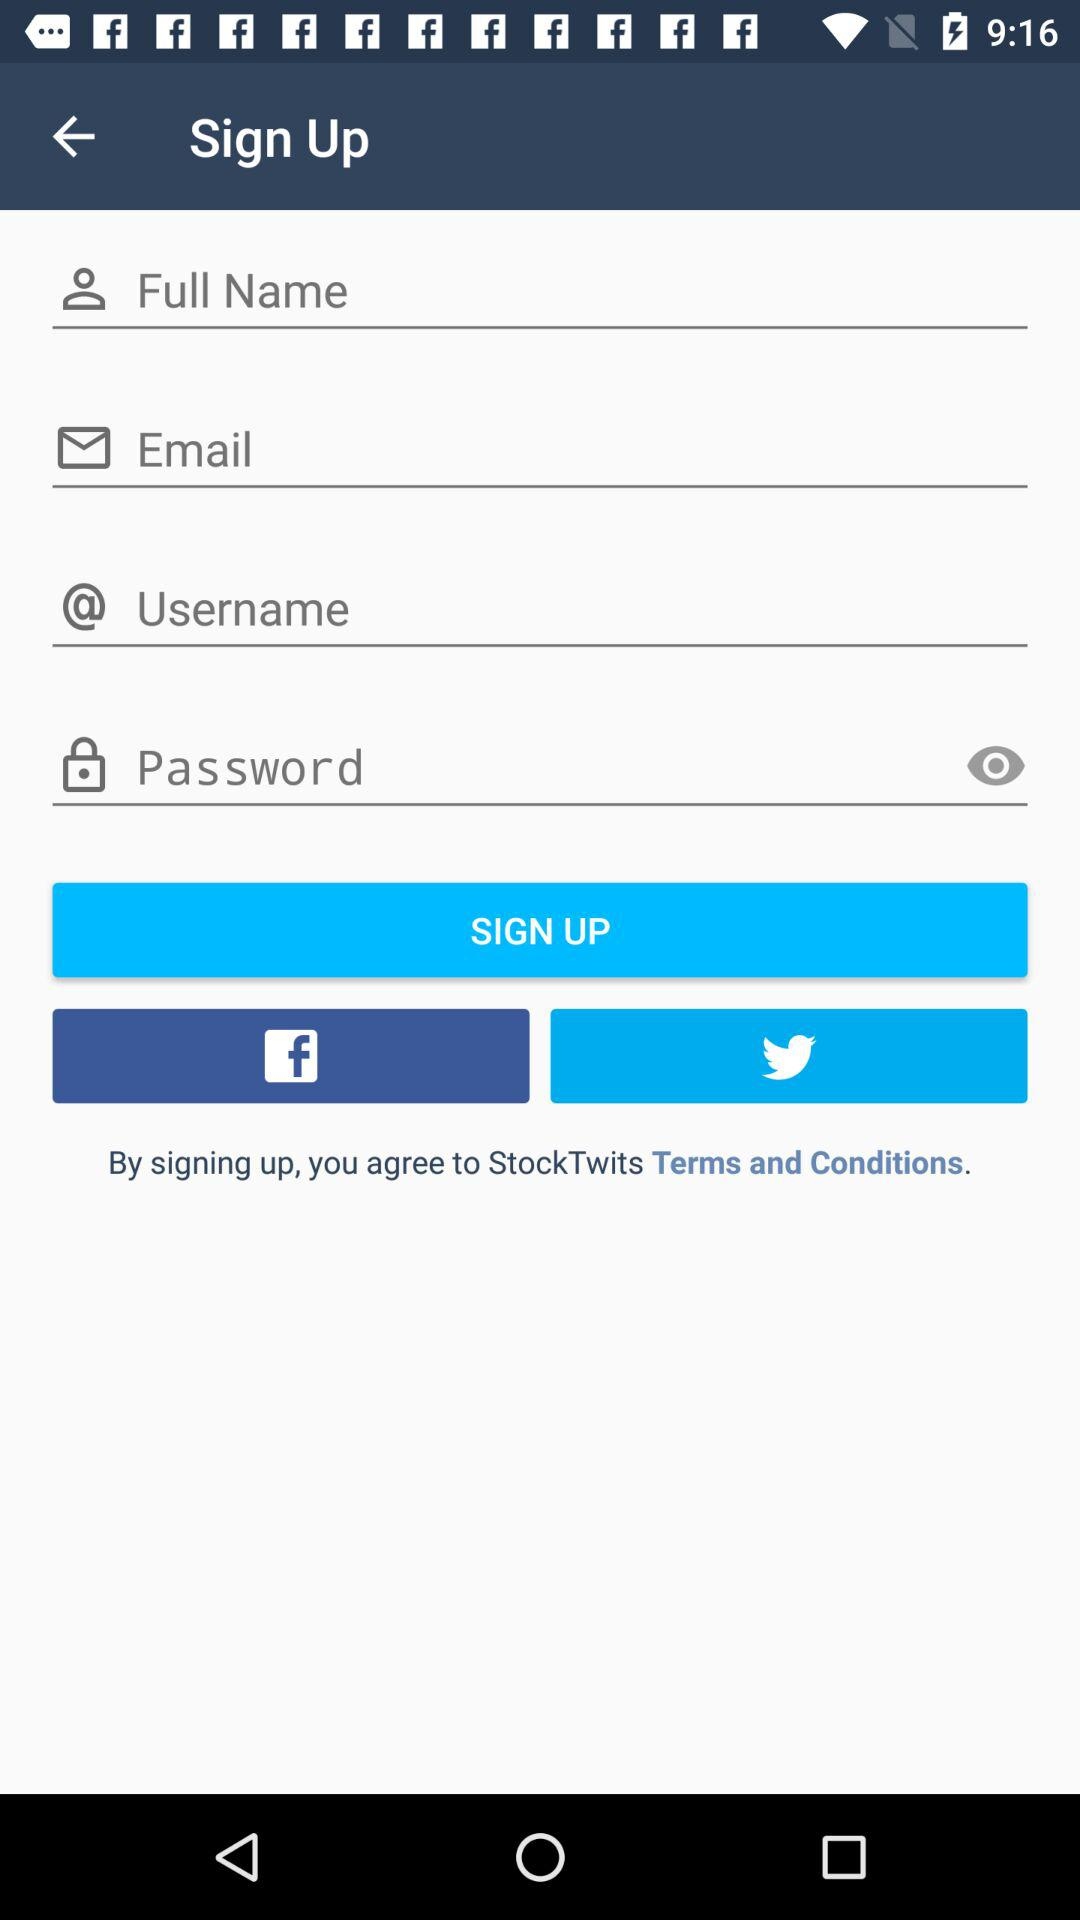How many characters does the password need?
When the provided information is insufficient, respond with <no answer>. <no answer> 